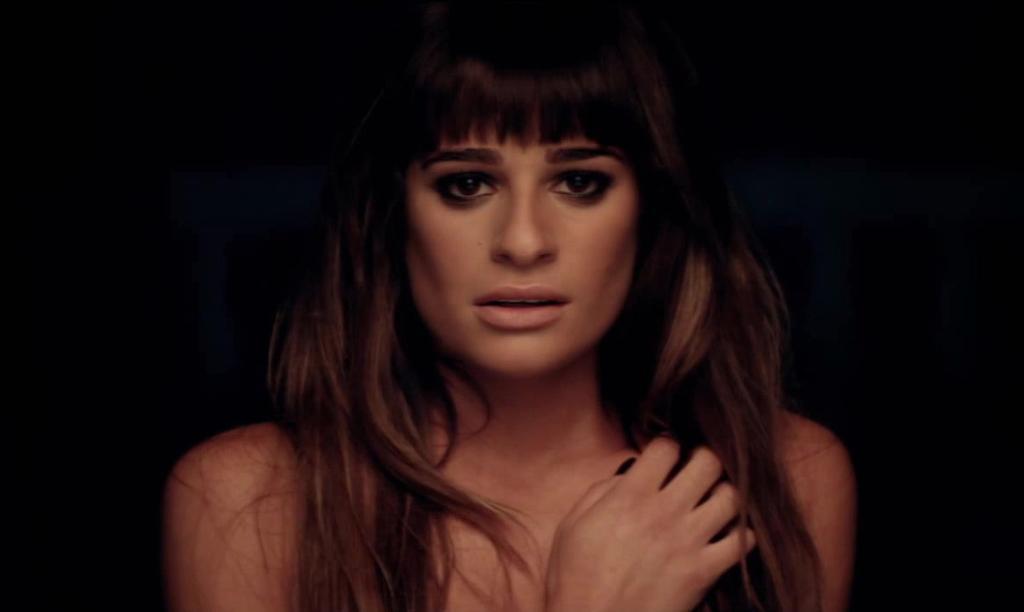Can you describe this image briefly? In this image we can see a woman. Background it is dark. 